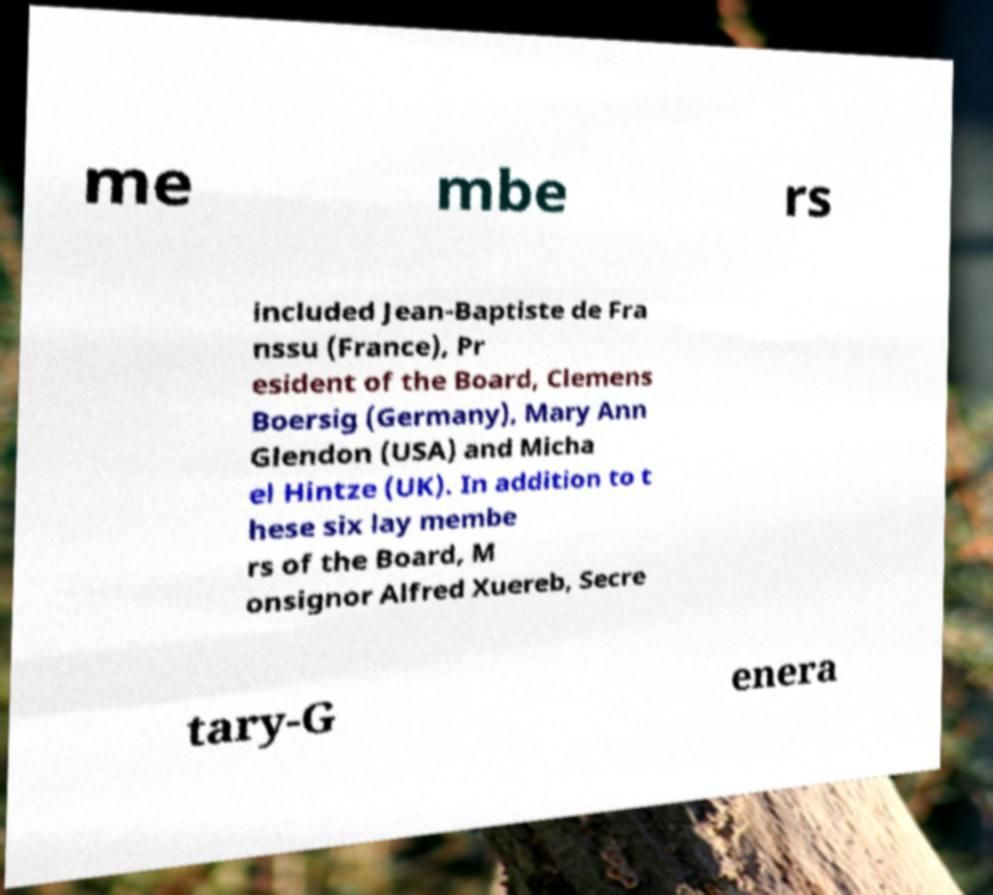Please identify and transcribe the text found in this image. me mbe rs included Jean-Baptiste de Fra nssu (France), Pr esident of the Board, Clemens Boersig (Germany), Mary Ann Glendon (USA) and Micha el Hintze (UK). In addition to t hese six lay membe rs of the Board, M onsignor Alfred Xuereb, Secre tary-G enera 